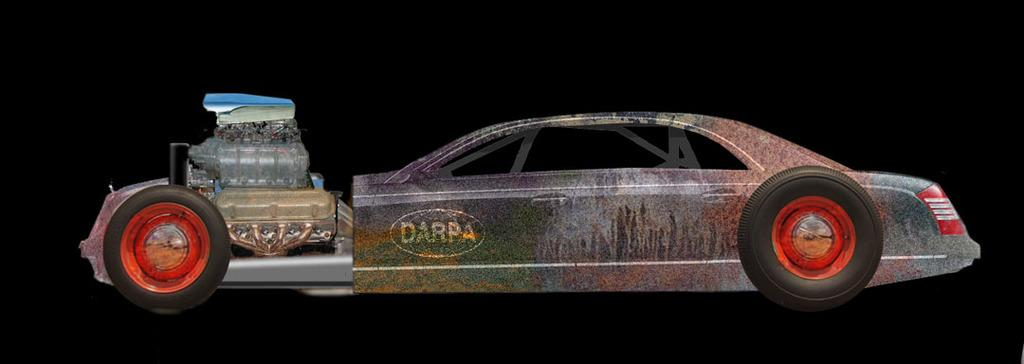What object is the main focus of the image? There is a toy vehicle in the image. What can be observed about the background of the image? The background of the image is dark. Where is the heart-shaped stream located in the image? There is no heart-shaped stream present in the image. 